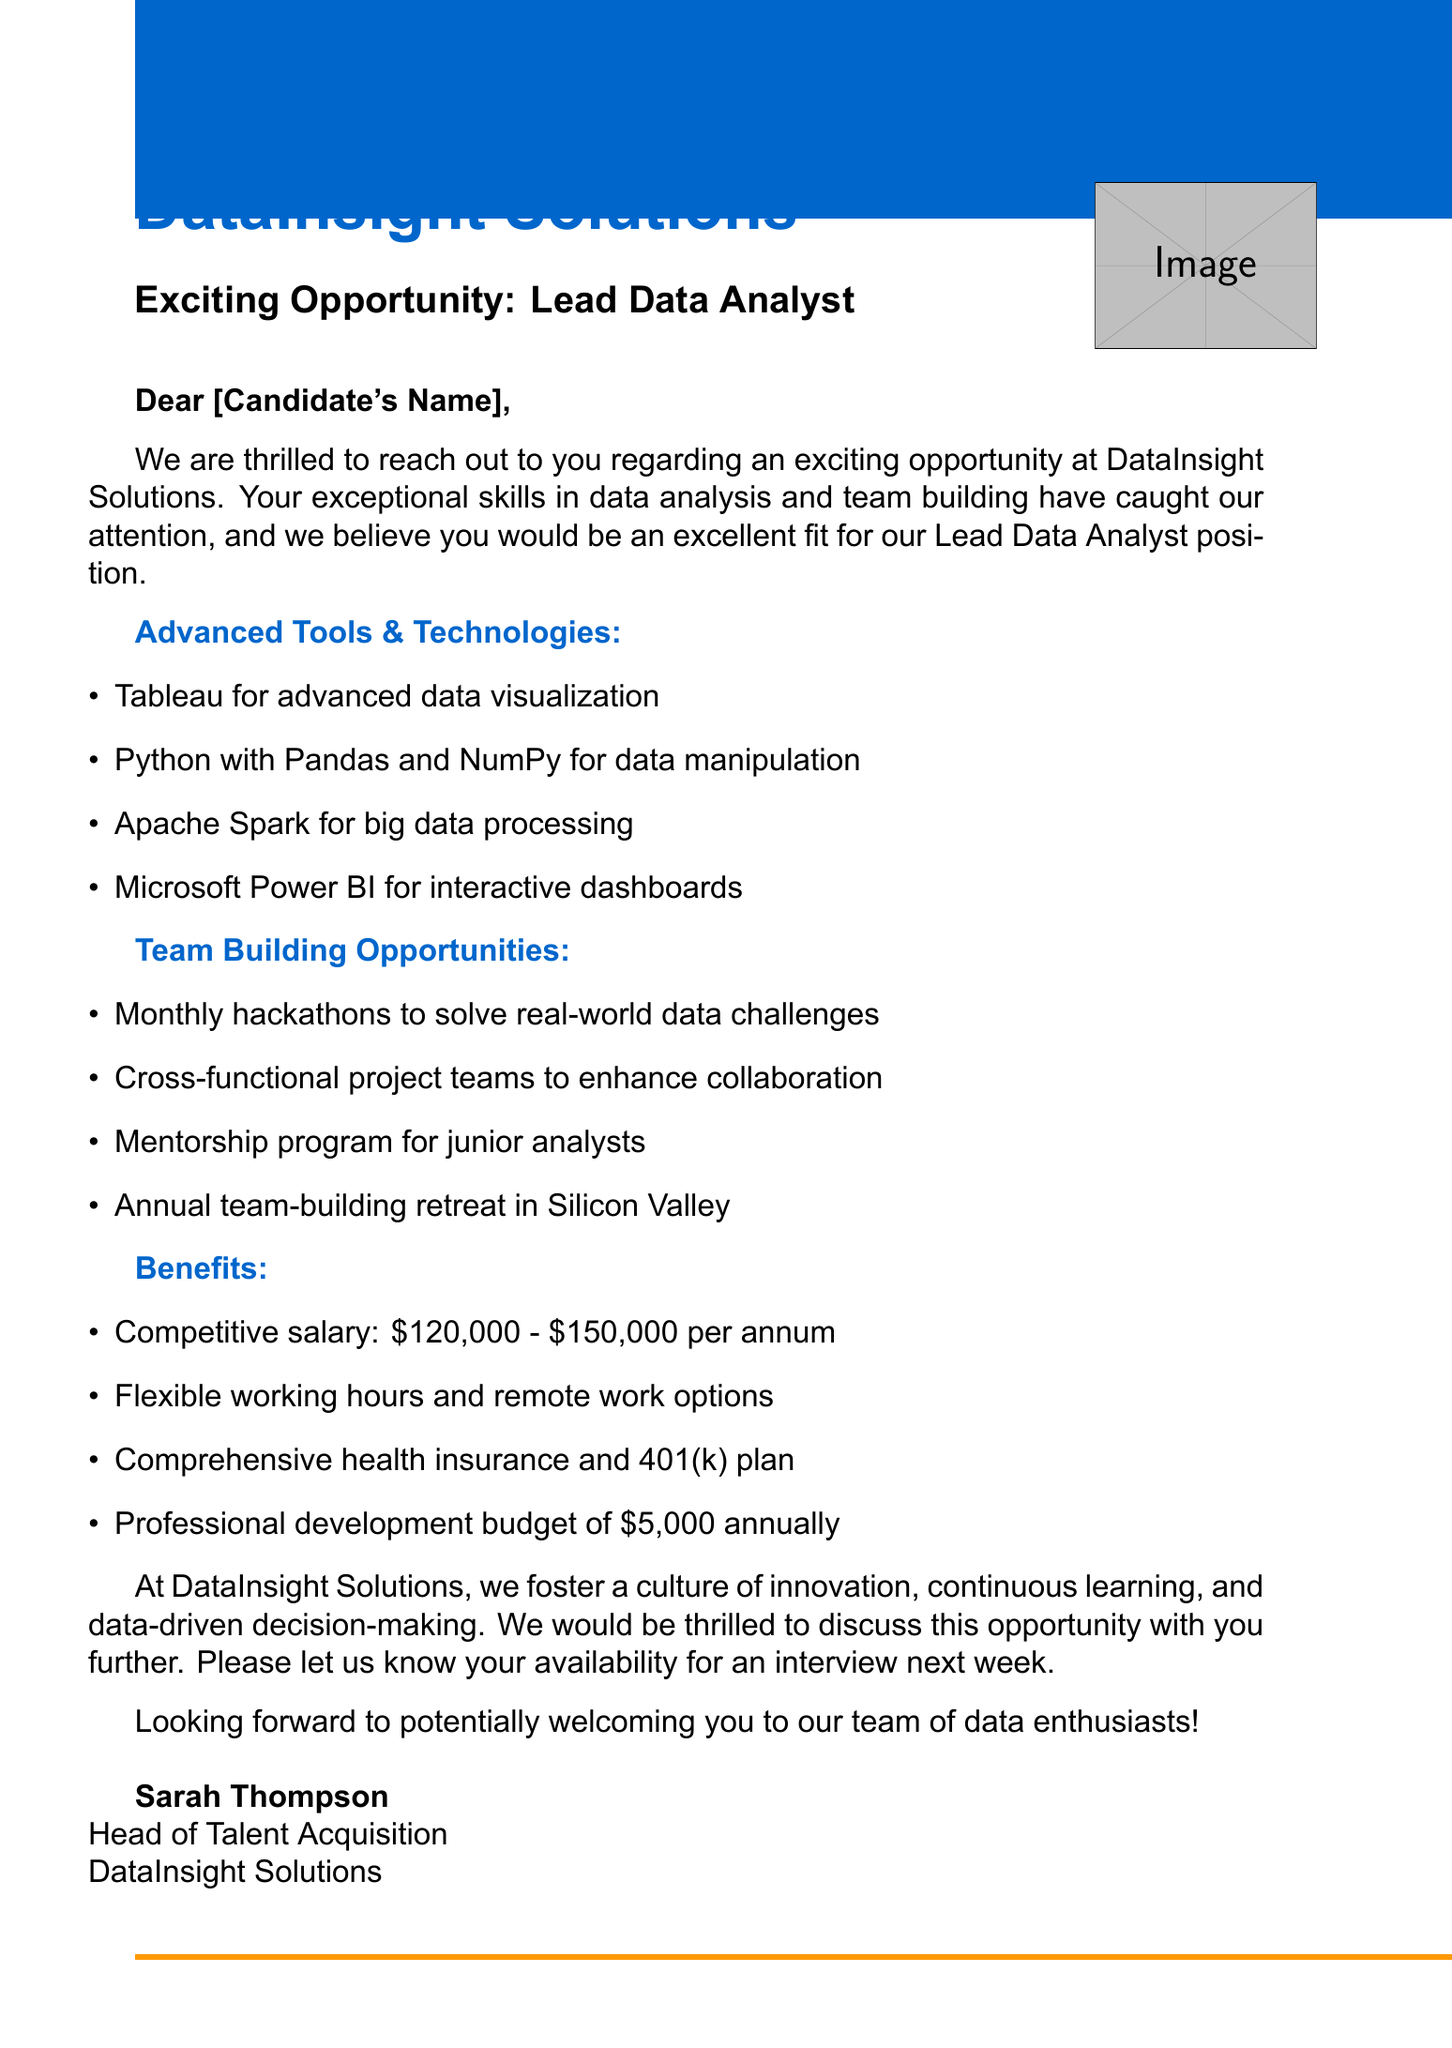What is the company name? The company name is stated in the introduction of the document.
Answer: DataInsight Solutions What position is being offered? The position is specified right in the subject line and introduction.
Answer: Lead Data Analyst What is the annual salary range for the position? The document lists the salary range in the benefits section.
Answer: $120,000 - $150,000 Which tool is mentioned for big data processing? This information can be found in the tools and technologies section of the document.
Answer: Apache Spark What type of team-building activity occurs annually? The document lists various team-building opportunities, specifically one that is annual.
Answer: Annual team-building retreat in Silicon Valley How much is the professional development budget per year? The benefits section clearly states this amount.
Answer: $5,000 What is a unique aspect of the company culture? The document highlights a specific cultural value at the end of the benefits section.
Answer: Innovation How can the candidate confirm their interest in the position? The call to action provides guidance on how to proceed.
Answer: Availability for an interview next week What is the greeting used in the document? The document starts with a specific form of greeting.
Answer: Dear [Candidate's Name] 